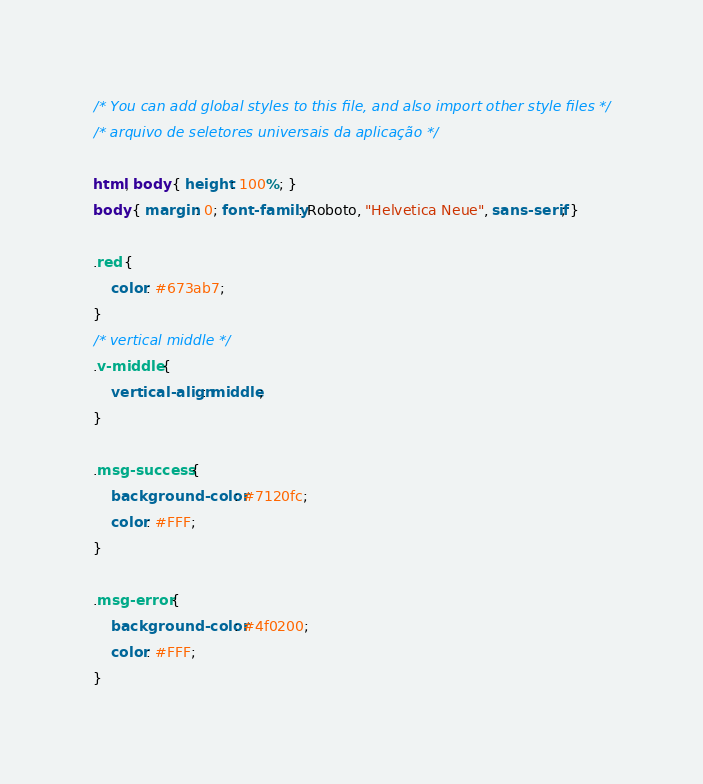<code> <loc_0><loc_0><loc_500><loc_500><_CSS_>/* You can add global styles to this file, and also import other style files */
/* arquivo de seletores universais da aplicação */

html, body { height: 100%; }
body { margin: 0; font-family: Roboto, "Helvetica Neue", sans-serif; }

.red { 
    color: #673ab7;
}
/* vertical middle */
.v-middle {
    vertical-align: middle;
}

.msg-success {
    background-color: #7120fc;
    color: #FFF;
}

.msg-error {
    background-color: #4f0200;
    color: #FFF;
}
</code> 